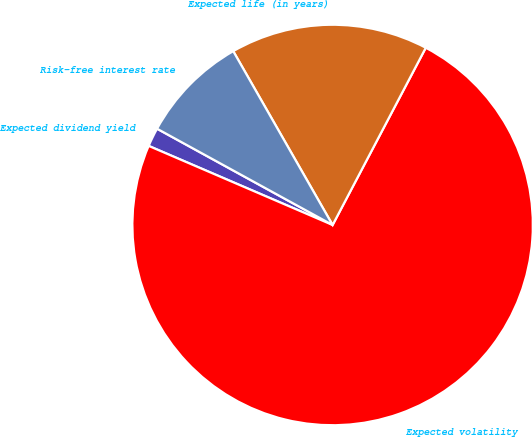Convert chart. <chart><loc_0><loc_0><loc_500><loc_500><pie_chart><fcel>Expected dividend yield<fcel>Expected volatility<fcel>Expected life (in years)<fcel>Risk-free interest rate<nl><fcel>1.52%<fcel>73.76%<fcel>15.97%<fcel>8.75%<nl></chart> 